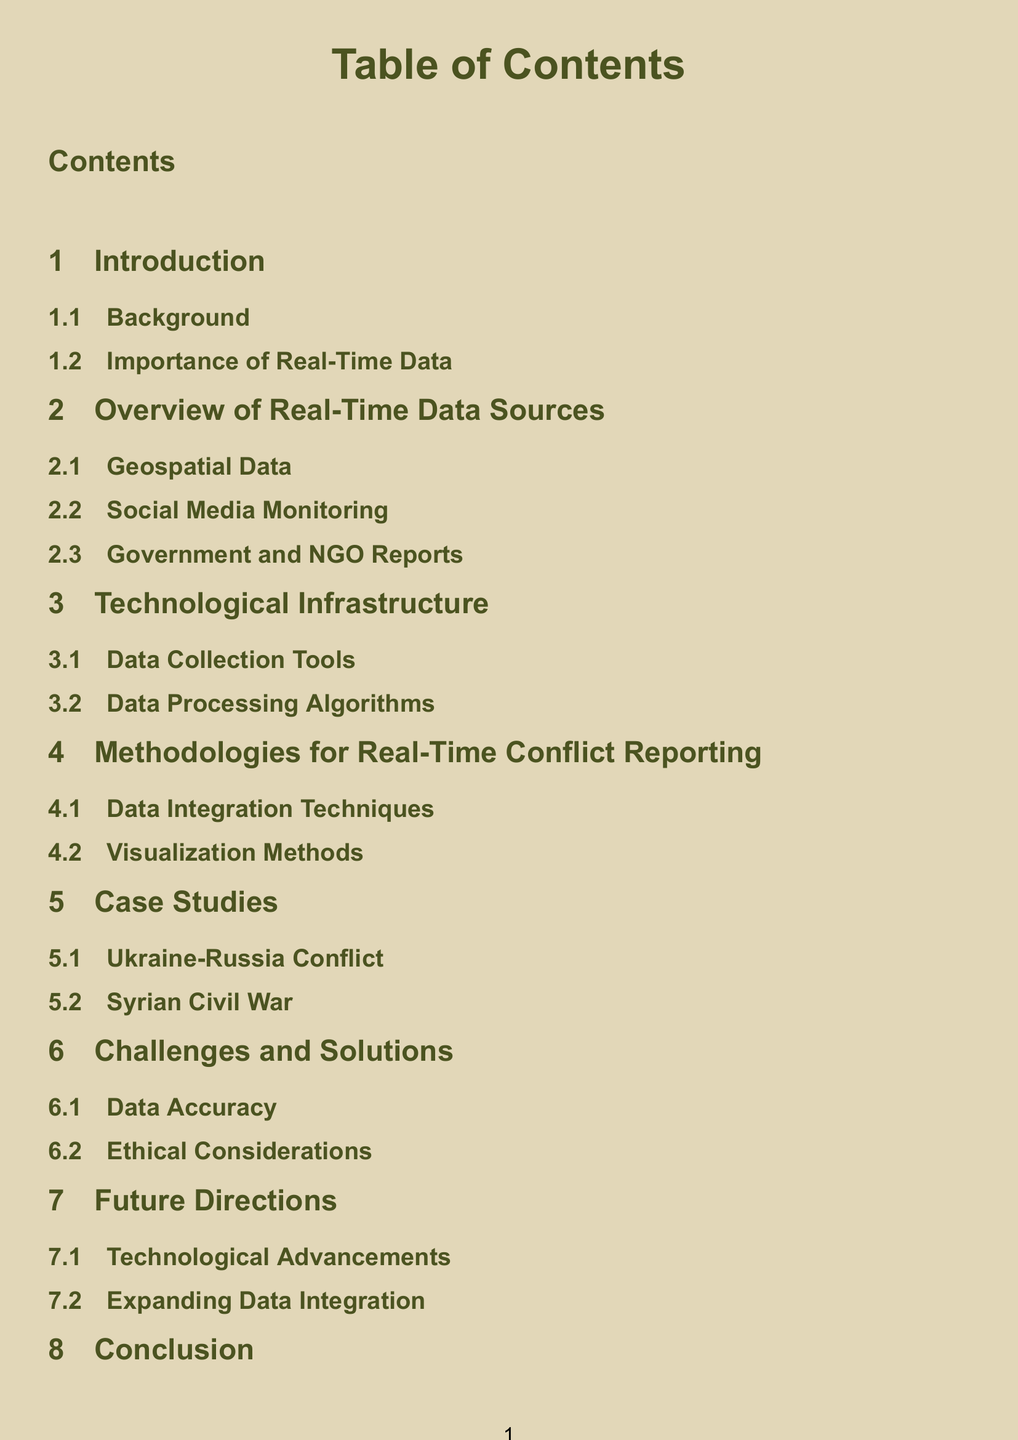What is the title of the document? The title of the document is presented prominently at the beginning and is “Table of Contents.”
Answer: Table of Contents How many sections are in the document? The document has a total of seven sections listed in the table of contents.
Answer: Seven What is the first subsection under the “Introduction” section? The first subsection listed under the “Introduction” section is “Background.”
Answer: Background Which conflict is used as a case study in the document? The document mentions two conflicts, one being the “Ukraine-Russia Conflict.”
Answer: Ukraine-Russia Conflict What is mentioned as a challenge in the document? One of the challenges identified in the document is “Data Accuracy.”
Answer: Data Accuracy What color is used for the section titles? The section titles in the document are colored “military green.”
Answer: Military green What is the last subsection in the document? The last subsection listed in the document is “Final Thoughts.”
Answer: Final Thoughts What technological aspect is mentioned under “Future Directions”? The subsection under “Future Directions” that refers to technological aspects is “Technological Advancements.”
Answer: Technological Advancements What type of data is highlighted as a source in the document? One type of data emphasized in the document for real-time reporting is “Geospatial Data.”
Answer: Geospatial Data 